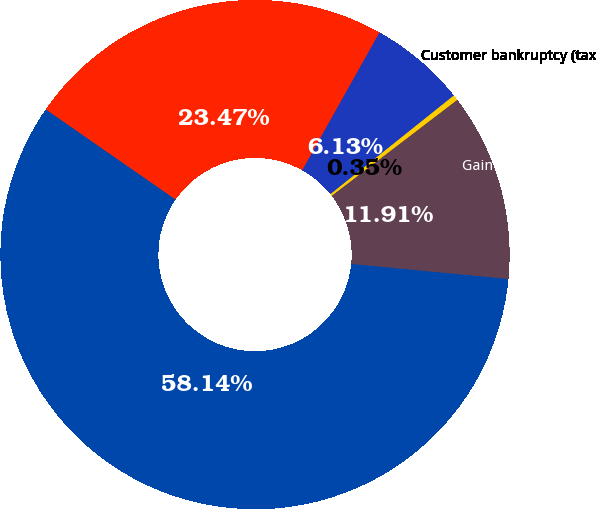Convert chart. <chart><loc_0><loc_0><loc_500><loc_500><pie_chart><fcel>2012 GAAP<fcel>Business restructuring and<fcel>Advisory costs (tax impact 37)<fcel>Customer bankruptcy (tax<fcel>Gain on previously held equity<nl><fcel>58.13%<fcel>23.47%<fcel>6.13%<fcel>0.35%<fcel>11.91%<nl></chart> 